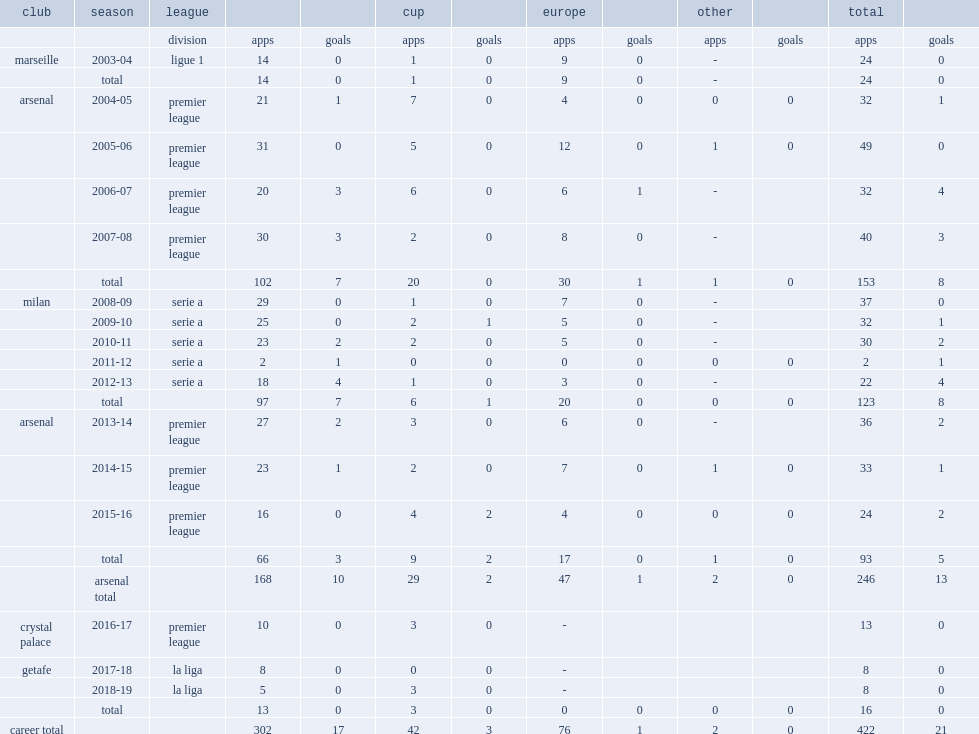Which club did flamini play for in 2007-08? Arsenal. 